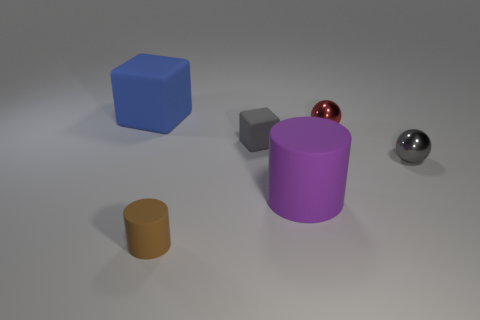Add 2 small gray objects. How many objects exist? 8 Subtract all cubes. How many objects are left? 4 Subtract 0 purple spheres. How many objects are left? 6 Subtract all tiny rubber objects. Subtract all big things. How many objects are left? 2 Add 4 small metal spheres. How many small metal spheres are left? 6 Add 6 small balls. How many small balls exist? 8 